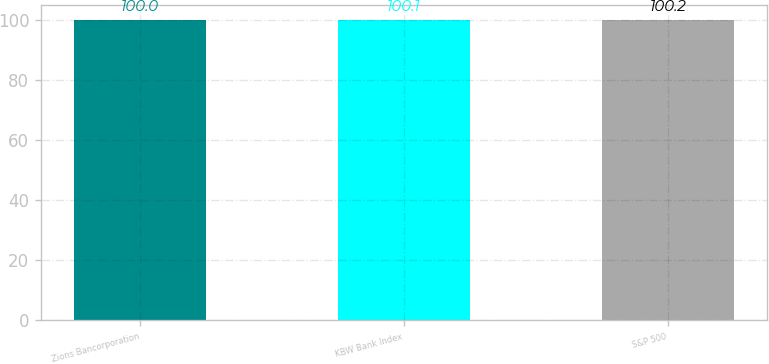Convert chart. <chart><loc_0><loc_0><loc_500><loc_500><bar_chart><fcel>Zions Bancorporation<fcel>KBW Bank Index<fcel>S&P 500<nl><fcel>100<fcel>100.1<fcel>100.2<nl></chart> 